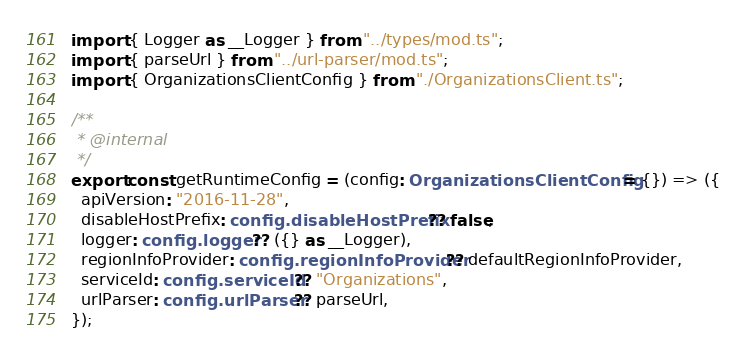<code> <loc_0><loc_0><loc_500><loc_500><_TypeScript_>import { Logger as __Logger } from "../types/mod.ts";
import { parseUrl } from "../url-parser/mod.ts";
import { OrganizationsClientConfig } from "./OrganizationsClient.ts";

/**
 * @internal
 */
export const getRuntimeConfig = (config: OrganizationsClientConfig = {}) => ({
  apiVersion: "2016-11-28",
  disableHostPrefix: config.disableHostPrefix ?? false,
  logger: config.logger ?? ({} as __Logger),
  regionInfoProvider: config.regionInfoProvider ?? defaultRegionInfoProvider,
  serviceId: config.serviceId ?? "Organizations",
  urlParser: config.urlParser ?? parseUrl,
});
</code> 